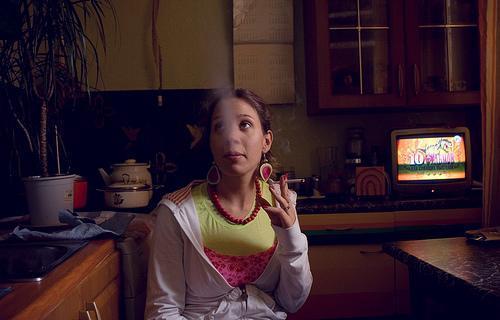How many glasses are on the counter?
Give a very brief answer. 0. How many people are there?
Give a very brief answer. 1. How many girls are sitting down?
Give a very brief answer. 1. How many stickers have a picture of a dog on them?
Give a very brief answer. 0. 